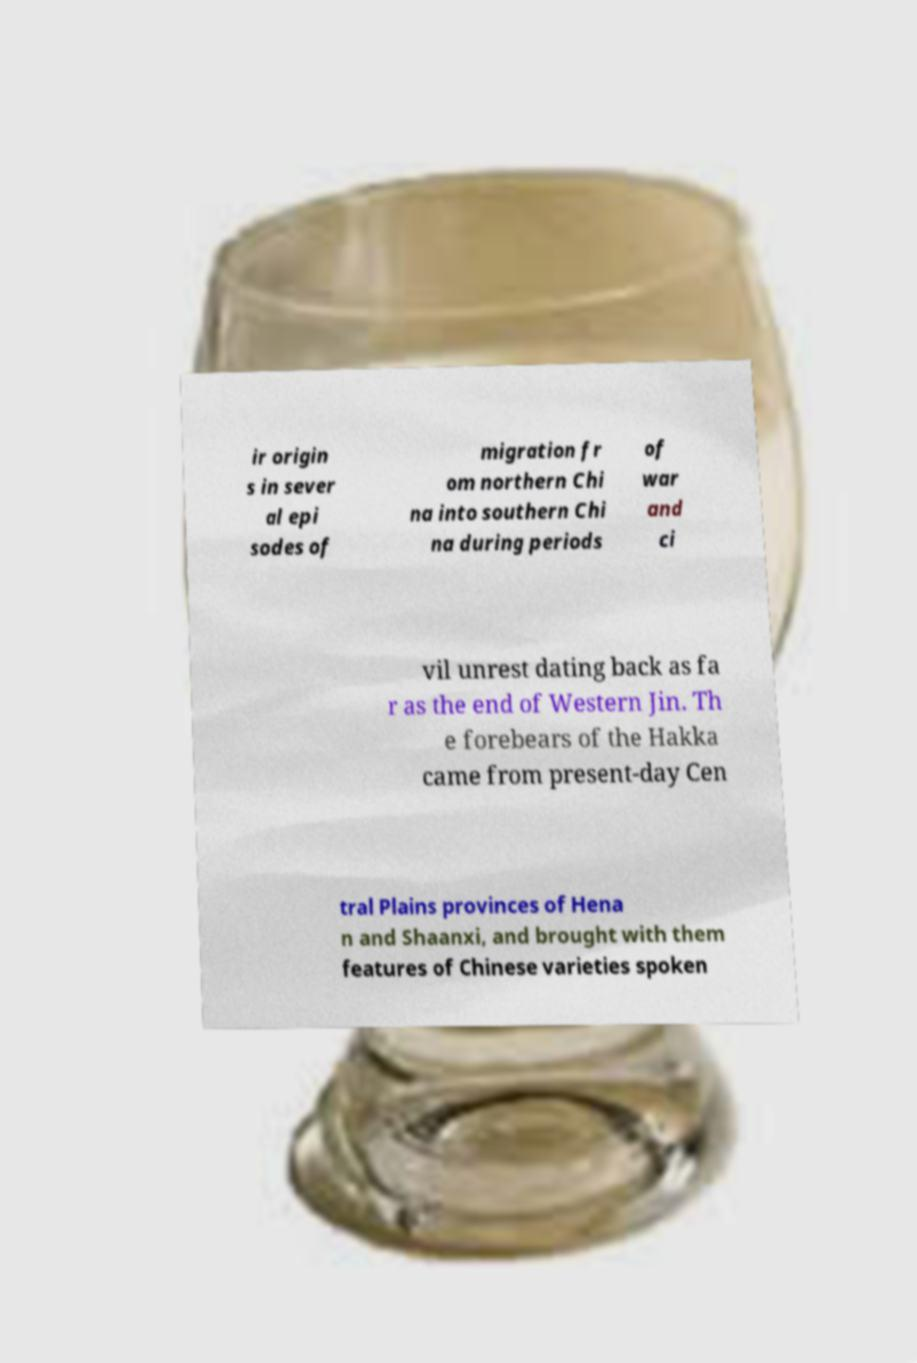I need the written content from this picture converted into text. Can you do that? ir origin s in sever al epi sodes of migration fr om northern Chi na into southern Chi na during periods of war and ci vil unrest dating back as fa r as the end of Western Jin. Th e forebears of the Hakka came from present-day Cen tral Plains provinces of Hena n and Shaanxi, and brought with them features of Chinese varieties spoken 